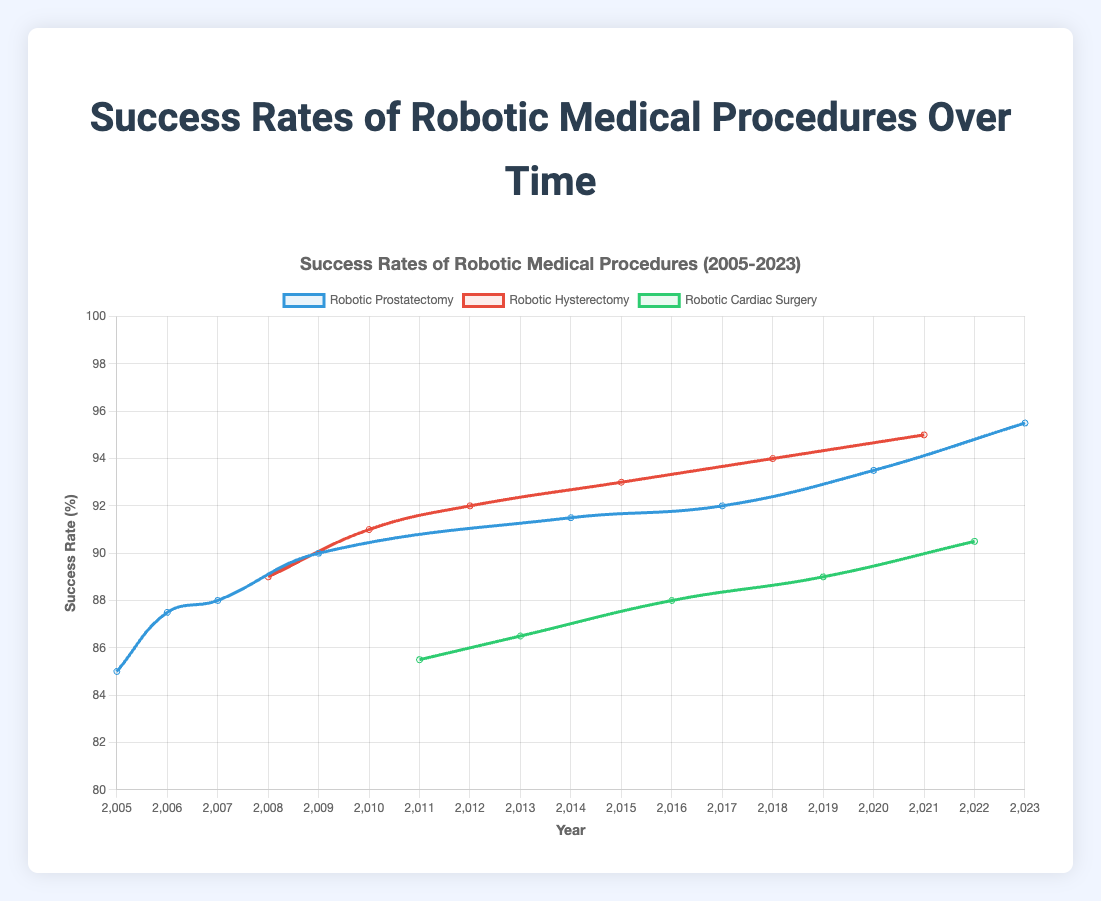Which procedure had the highest success rate in 2023? To determine which procedure had the highest success rate in 2023, look at the data points for each procedure in that year. The "Robotic Prostatectomy" had a success rate of 95.5% in 2023, which is higher than the others.
Answer: Robotic Prostatectomy How has the success rate of Robotic Hysterectomy changed from 2008 to 2021? Identify the success rates of "Robotic Hysterectomy" in 2008 (89.0%) and 2021 (95.0%). Calculate the difference: 95.0% - 89.0% = 6.0%, showing an increase.
Answer: Increased by 6.0% Which procedure had the least improvement in success rate from its initial year to 2023? The procedures started in different years: "Robotic Prostatectomy" in 2005, "Robotic Hysterectomy" in 2008, and "Robotic Cardiac Surgery" in 2011. Calculate the difference in success rates from their start year to 2023: "Robotic Prostatectomy" improved by 95.5% - 85.0% = 10.5%, "Robotic Hysterectomy" by 95.0% - 89.0% = 6.0%, and "Robotic Cardiac Surgery" by 90.5% - 85.5% = 5.0%. The least improvement is for "Robotic Cardiac Surgery" with 5.0%.
Answer: Robotic Cardiac Surgery Compare the success rates of the procedures in 2011. Which had the highest and lowest rates? Check the success rates for each procedure in 2011: "Robotic Prostatectomy" is not listed, "Robotic Hysterectomy" is not listed, and "Robotic Cardiac Surgery" has 85.5%. Thus, "Robotic Cardiac Surgery" has both the highest and lowest success rates as it is the only recorded procedure for 2011.
Answer: Robotic Cardiac Surgery (both highest and lowest) What is the average success rate of Robotic Prostatectomy over the recorded years? List the success rates for "Robotic Prostatectomy": 85.0, 87.5, 88.0, 90.0, 91.5, 92.0, 93.5, and 95.5. Sum these rates and divide by the number of years: (85.0 + 87.5 + 88.0 + 90.0 + 91.5 + 92.0 + 93.5 + 95.5) / 8 = 723.0 / 8 = 90.375.
Answer: 90.375 Which procedure showed a consistent increase in success rate every time it appears in the graph? Check each data point for consistent increases: "Robotic Prostatectomy" fluctuates, "Robotic Hysterectomy" consistently increases (89.0 to 91.0 to 92.0 to 93.0 to 94.0 to 95.0), and "Robotic Cardiac Surgery" fluctuates. Therefore, "Robotic Hysterectomy" shows a consistent increase.
Answer: Robotic Hysterectomy What is the median success rate of Robotic Cardiac Surgery across all years? List the success rates for "Robotic Cardiac Surgery": 85.5, 86.5, 88.0, 89.0, 90.5. To find the median, sort the rates and identify the middle value in this odd-numbered list: 85.5, 86.5, 88.0, 89.0, 90.5. The median is 88.0.
Answer: 88.0 In what year did Robotic Hysterectomy surpass a 90% success rate for the first time? Look at the success rates for each year "Robotic Hysterectomy" appears and find the first year it surpasses 90%. In 2010, it reached 91.0%, surpassing 90% for the first time.
Answer: 2010 Is there any year where "Robotic Prostatectomy" was not recorded? Check each year in the data to see if "Robotic Prostatectomy" is recorded. It is missing in 2008, 2010, 2011, 2012, 2013, 2015, 2016, 2018, 2019, 2021, 2022.
Answer: Yes (several years, including 2008 and 2010) 